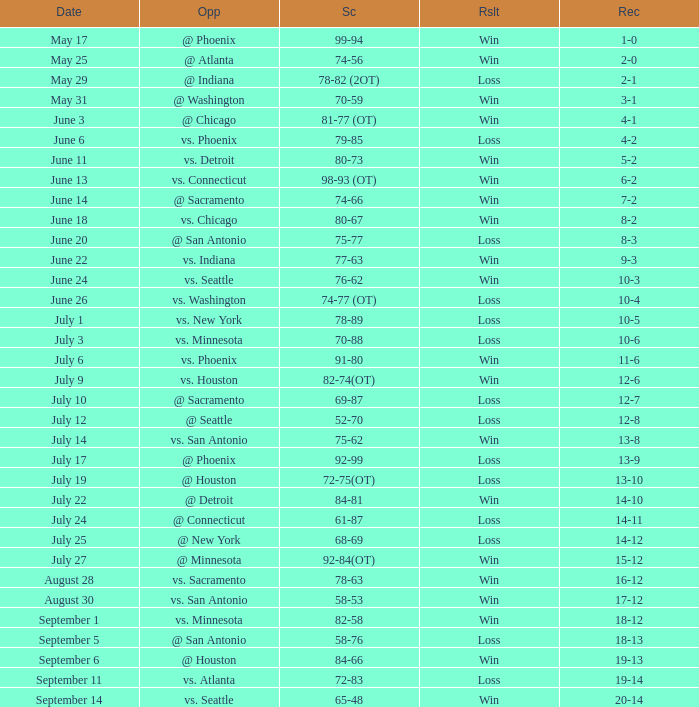What is the Score of the game @ San Antonio on June 20? 75-77. 